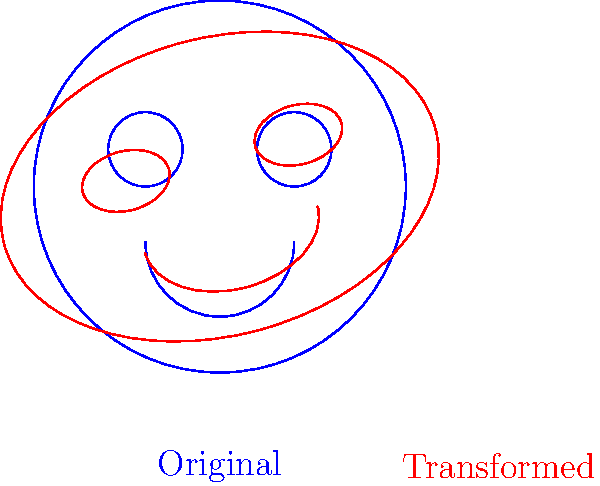In creating a digital illustration of Lisa Simpson, you apply two transformations to her face: first, a scaling transformation $T_1 = \begin{pmatrix} 1.2 & 0 \\ 0 & 0.8 \end{pmatrix}$, followed by a rotation transformation $T_2 = \begin{pmatrix} \cos 15° & -\sin 15° \\ \sin 15° & \cos 15° \end{pmatrix}$. What is the resulting transformation matrix when these are applied in sequence? To find the resulting transformation matrix, we need to multiply the matrices $T_2$ and $T_1$ in the correct order:

1) First, let's write out $T_2$ in its exact form:
   $T_2 = \begin{pmatrix} \cos 15° & -\sin 15° \\ \sin 15° & \cos 15° \end{pmatrix}$

2) Now, we multiply $T_2$ and $T_1$:
   $T_2 \cdot T_1 = \begin{pmatrix} \cos 15° & -\sin 15° \\ \sin 15° & \cos 15° \end{pmatrix} \cdot \begin{pmatrix} 1.2 & 0 \\ 0 & 0.8 \end{pmatrix}$

3) Multiplying these matrices:
   $= \begin{pmatrix} 
   (1.2 \cos 15°) & (-0.8 \sin 15°) \\
   (1.2 \sin 15°) & (0.8 \cos 15°)
   \end{pmatrix}$

4) Calculating the values (rounded to 4 decimal places):
   $\cos 15° \approx 0.9659$
   $\sin 15° \approx 0.2588$

5) Substituting these values:
   $= \begin{pmatrix} 
   (1.2 \cdot 0.9659) & (-0.8 \cdot 0.2588) \\
   (1.2 \cdot 0.2588) & (0.8 \cdot 0.9659)
   \end{pmatrix}$

6) Final result (rounded to 4 decimal places):
   $= \begin{pmatrix} 
   1.1591 & -0.2070 \\
   0.3106 & 0.7727
   \end{pmatrix}$
Answer: $\begin{pmatrix} 
1.1591 & -0.2070 \\
0.3106 & 0.7727
\end{pmatrix}$ 